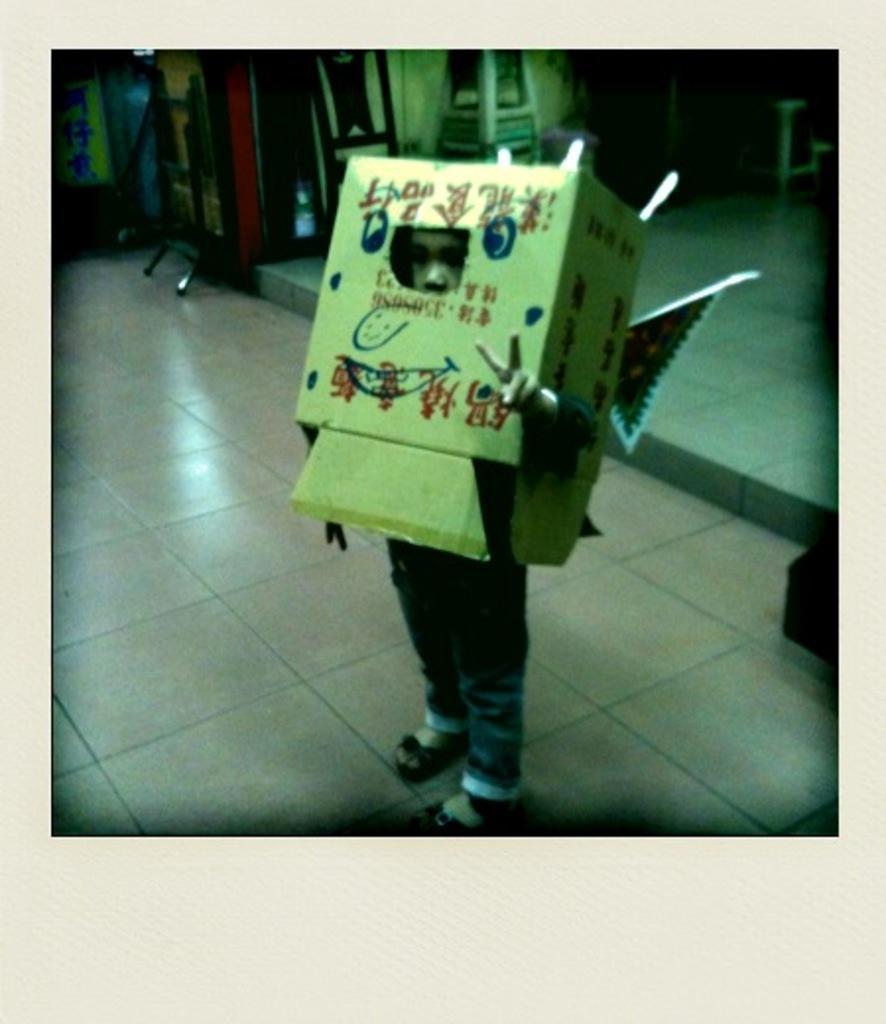Can you describe this image briefly? In this image we can see a boy standing on the floor and he has covered his face with a packing box. 